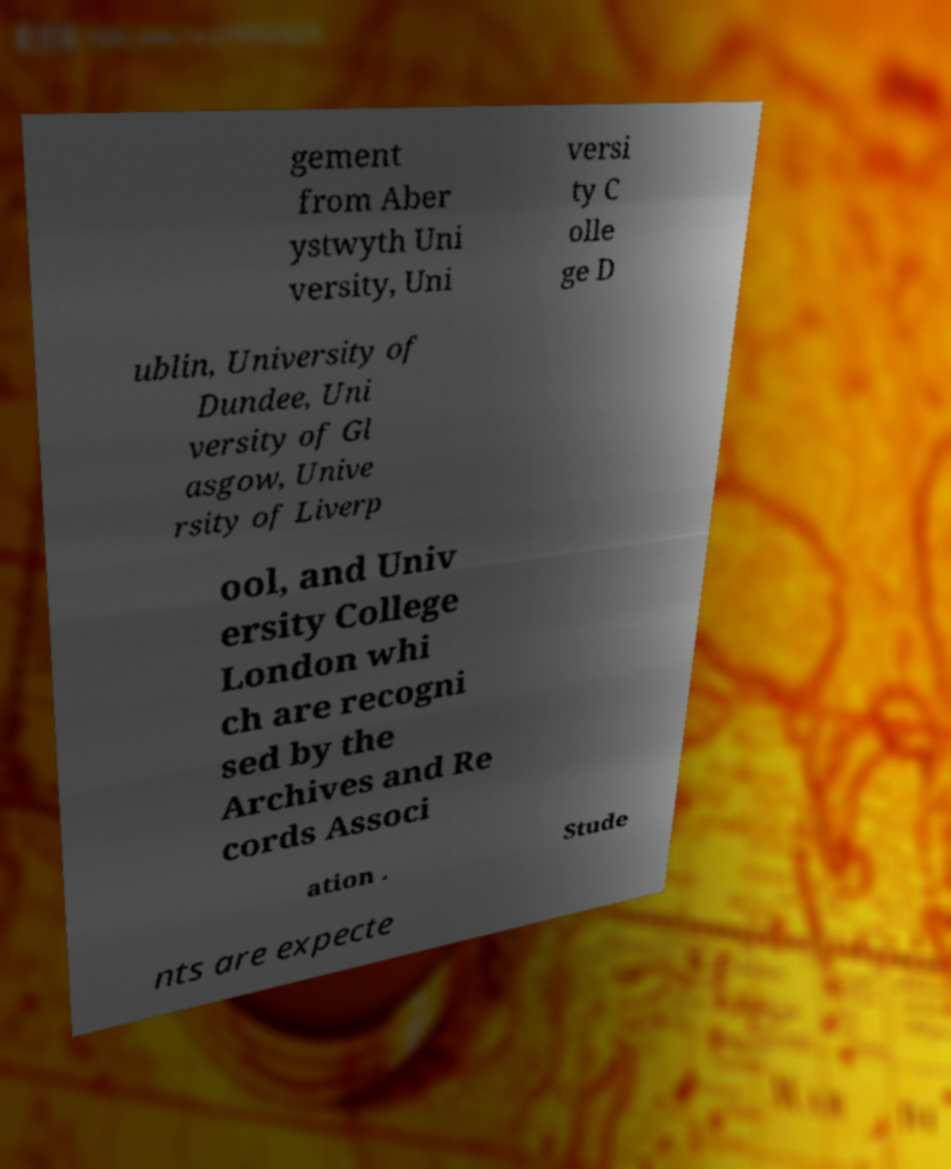For documentation purposes, I need the text within this image transcribed. Could you provide that? gement from Aber ystwyth Uni versity, Uni versi ty C olle ge D ublin, University of Dundee, Uni versity of Gl asgow, Unive rsity of Liverp ool, and Univ ersity College London whi ch are recogni sed by the Archives and Re cords Associ ation . Stude nts are expecte 